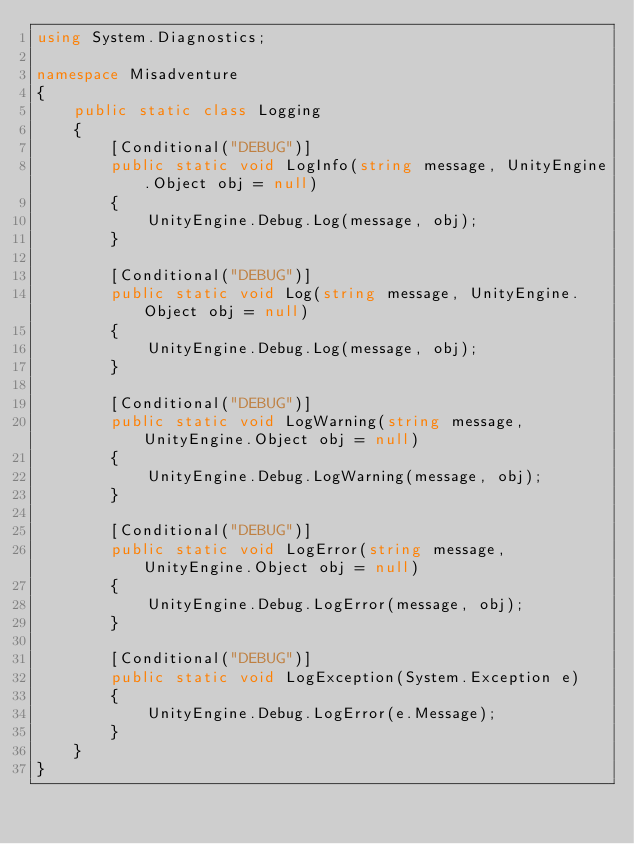Convert code to text. <code><loc_0><loc_0><loc_500><loc_500><_C#_>using System.Diagnostics;

namespace Misadventure
{
    public static class Logging
    {
        [Conditional("DEBUG")]
        public static void LogInfo(string message, UnityEngine.Object obj = null)
        {
            UnityEngine.Debug.Log(message, obj);
        }

        [Conditional("DEBUG")]
        public static void Log(string message, UnityEngine.Object obj = null)
        {
            UnityEngine.Debug.Log(message, obj);
        }

        [Conditional("DEBUG")]
        public static void LogWarning(string message, UnityEngine.Object obj = null)
        {
            UnityEngine.Debug.LogWarning(message, obj);
        }

        [Conditional("DEBUG")]
        public static void LogError(string message, UnityEngine.Object obj = null)
        {
            UnityEngine.Debug.LogError(message, obj);
        }

        [Conditional("DEBUG")]
        public static void LogException(System.Exception e)
        {
            UnityEngine.Debug.LogError(e.Message);
        }
    }
}</code> 